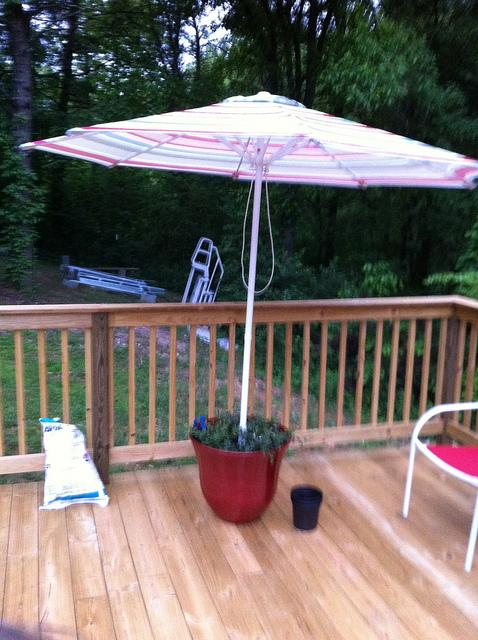What is inside the flower pot?

Choices:
A) umbrella
B) cat
C) baby
D) single rose umbrella 